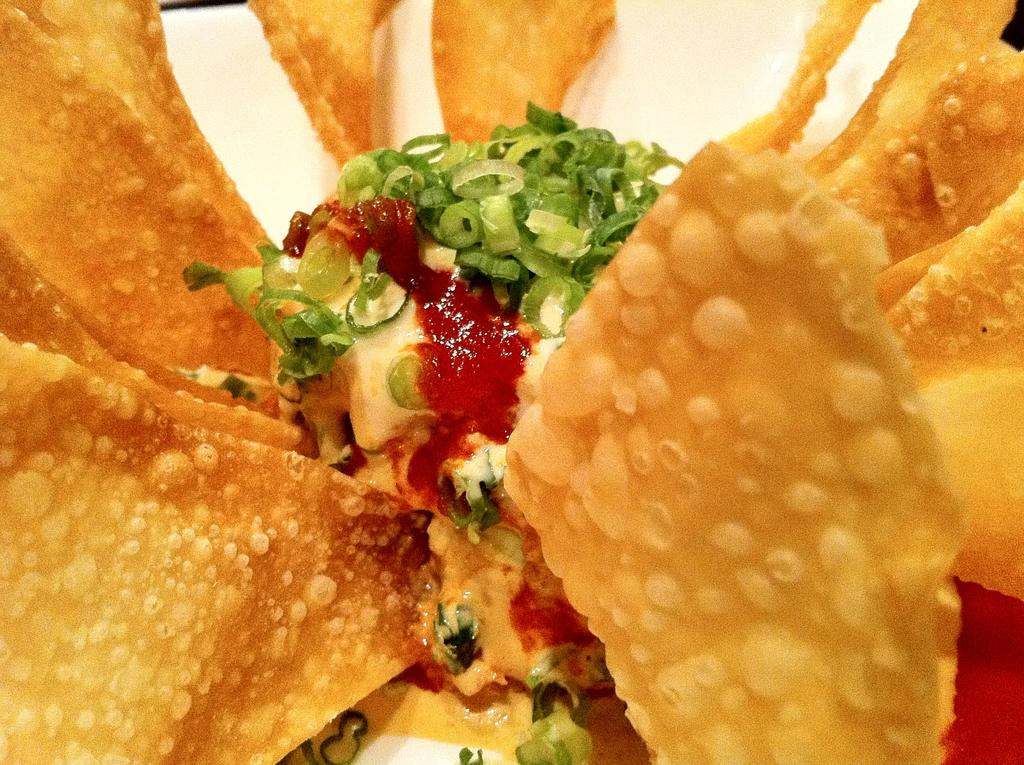What type of food is featured in the image? There is a salad in the image. What ingredients can be found in the salad? The salad contains vegetable slices. Is there any additional component to the salad? Yes, the salad has sauce. What other type of food is present in the image? There are chips in a plate in the image. Where is the deer located in the image? There is no deer present in the image. What is the yoke used for in the image? There is no yoke present in the image. 